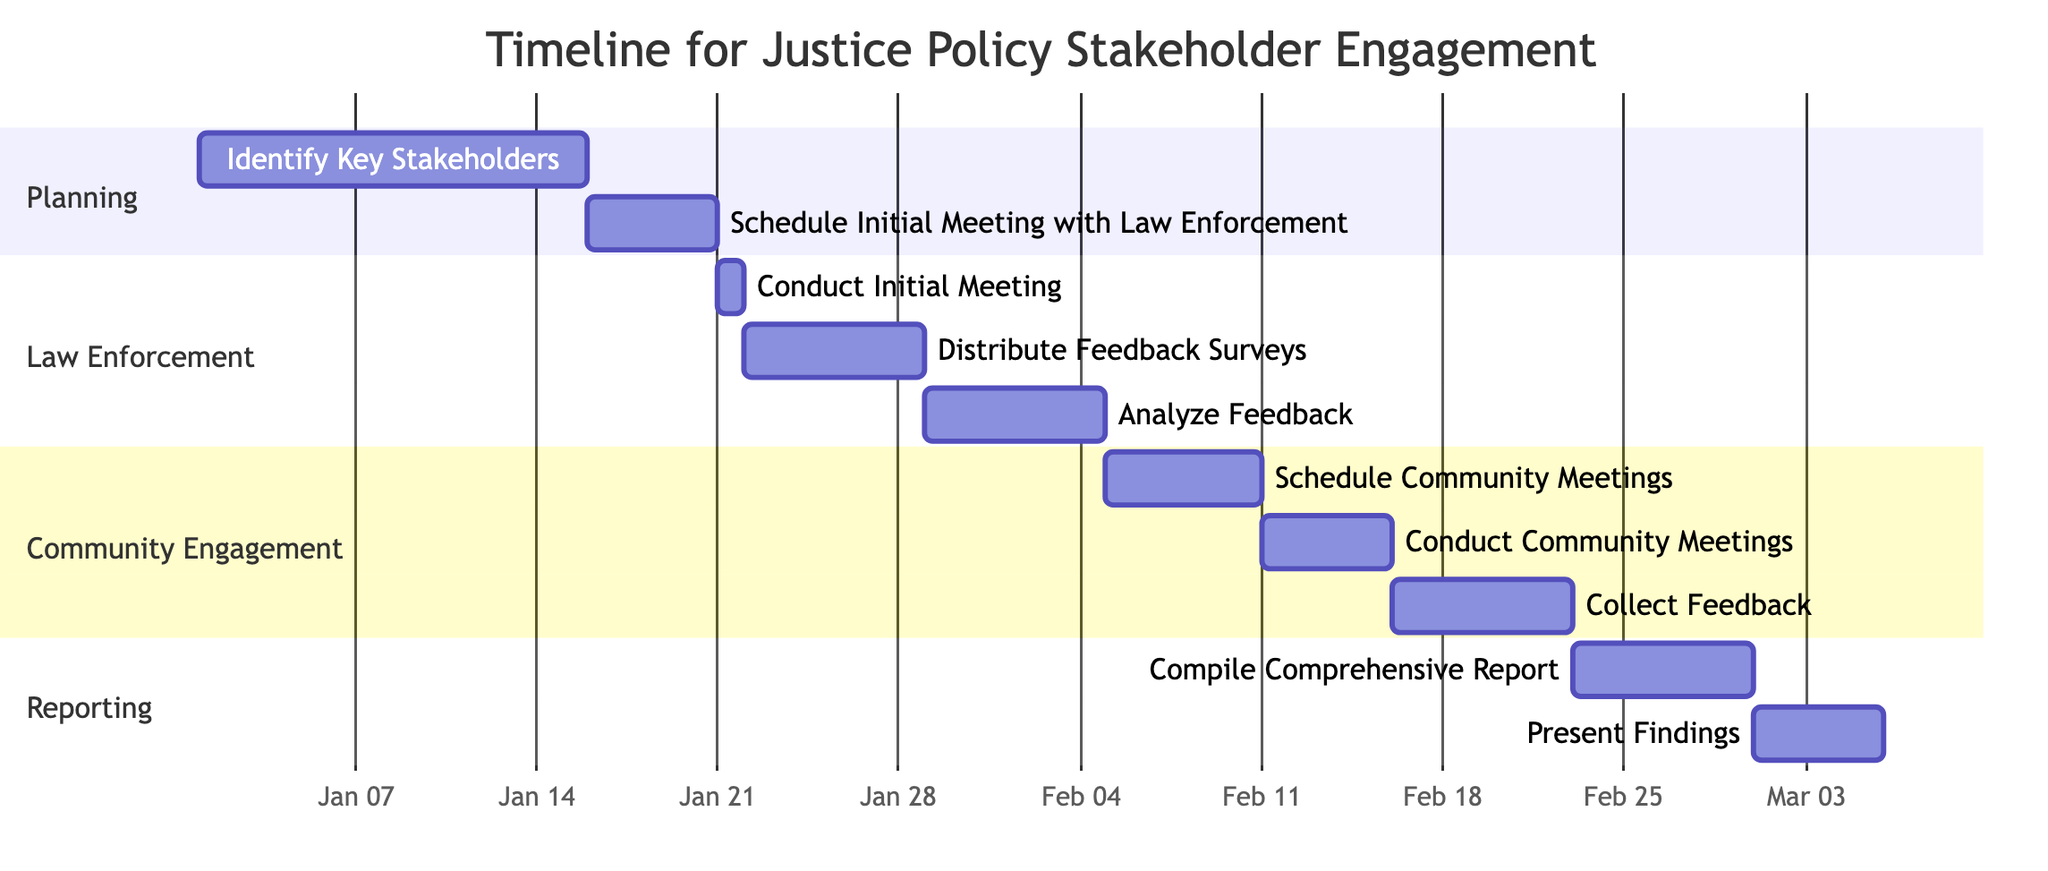What is the duration for identifying key stakeholders? The task "Identify Key Stakeholders" starts on January 1, 2024, and ends on January 15, 2024. The duration is 15 days.
Answer: 15 days What task follows the scheduling of the initial meeting with law enforcement agencies? The task following "Schedule Initial Meeting with Law Enforcement Agencies" is "Conduct Initial Meeting with Law Enforcement Agencies". This is observed in the timeline immediately after the initial scheduling task.
Answer: Conduct Initial Meeting with Law Enforcement Agencies How many days are allocated for collecting feedback from community organizations? The task "Collect Feedback from Community Organizations" starts on February 16, 2024, and ends on February 22, 2024, which gives it a duration of 7 days.
Answer: 7 days Which task has the earliest start date? The task "Identify Key Stakeholders" begins on January 1, 2024, making it the task with the earliest start date in the entire Gantt chart.
Answer: Identify Key Stakeholders What is the total number of tasks in the Gantt chart? Counting all the distinct tasks listed in the chart, there are a total of 10 tasks, which can be confirmed by enumerating each task in the provided data.
Answer: 10 tasks How long after the initial meeting is feedback from law enforcement analyzed? The "Conduct Initial Meeting with Law Enforcement Agencies" occurs on January 21, 2024, and feedback analysis starts on January 29, 2024. This results in a gap of 8 days between these two tasks.
Answer: 8 days What is the last task to be completed in the timeline? The final task listed is "Present Findings to Justice Policy Advisory Board," which is scheduled to be completed by March 5, 2024. This indicates it's the last activity in the workflow.
Answer: Present Findings to Justice Policy Advisory Board Which section contains the task for distributing feedback surveys? The task "Distribute Feedback Surveys to Law Enforcement Agencies" is part of the "Law Enforcement" section, as categorized in the Gantt chart.
Answer: Law Enforcement What is the time frame for compiling the comprehensive report? The task "Compile Comprehensive Report on Feedback" starts on February 23, 2024, and ends on February 29, 2024, resulting in a duration of 7 days for this task.
Answer: 7 days 